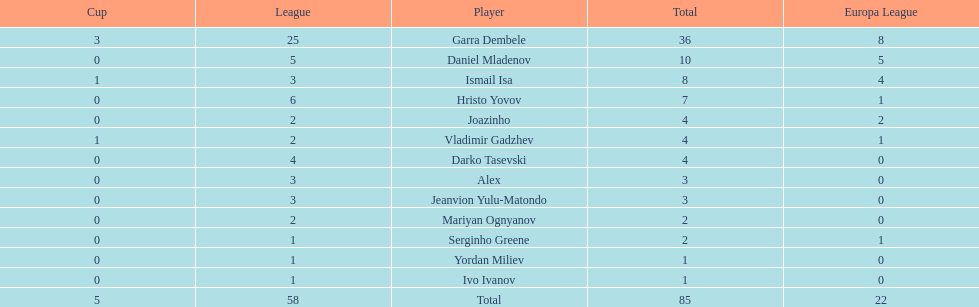Who was the top goalscorer on this team? Garra Dembele. 